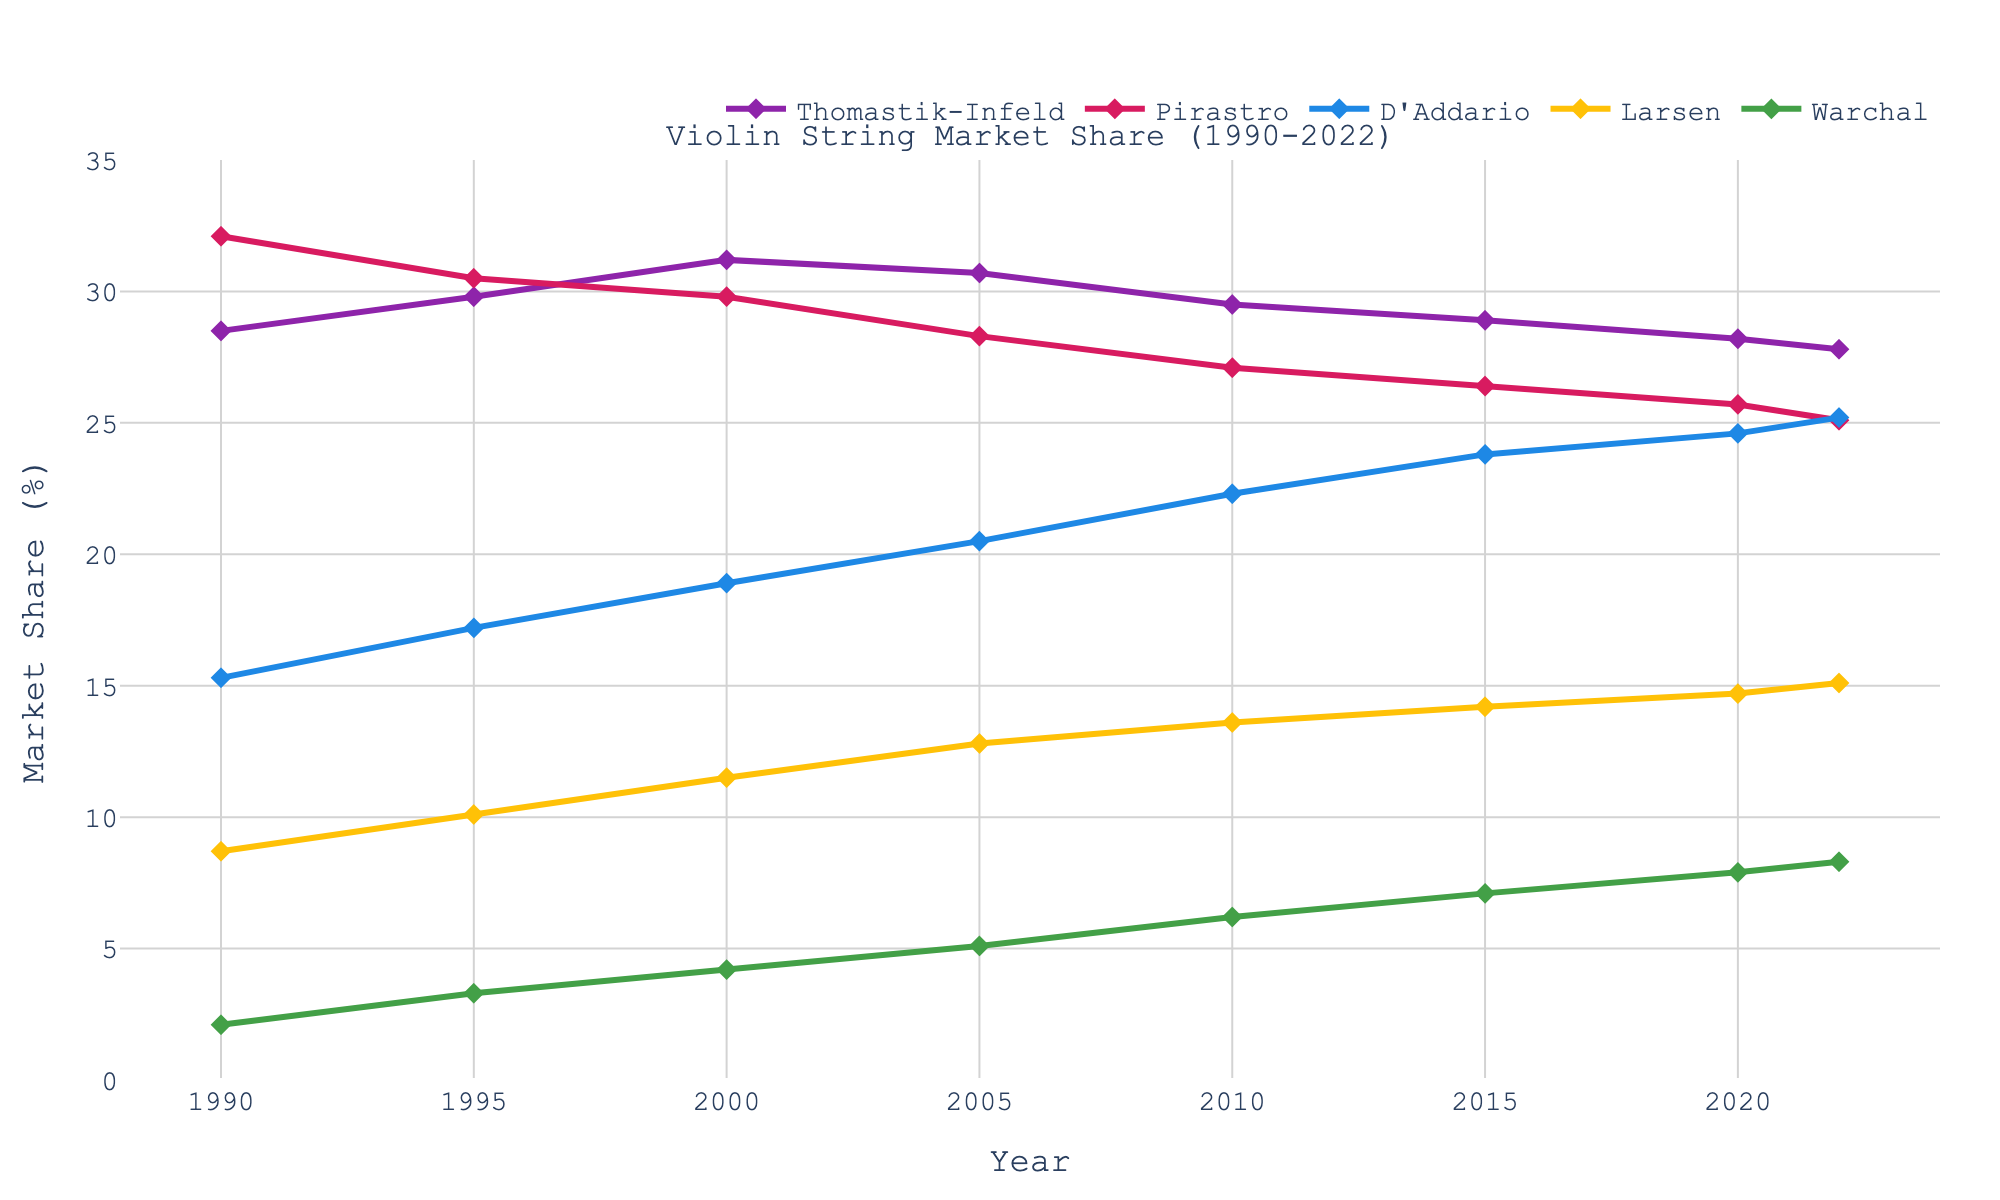Which manufacturer had the highest market share in 1990? Look at the year 1990 on the x-axis and find the highest point among the different colored lines. Thomastik-Infeld, Pirastro, D'Addario, Larsen, and Warchal are plotted. Pirastro is at the highest point with approximately 32.1%.
Answer: Pirastro What is the trend in market share for D'Addario from 1990 to 2022? Observe the D'Addario line (blue) across the years. The market share increases steadily from 15.3% in 1990 to 25.2% in 2022.
Answer: Increasing Which two manufacturers had the closest market share in 2005? Look at the year 2005 on the x-axis and compare the values for each manufacturer. Thomastik-Infeld is around 30.7%, Pirastro is around 28.3%, D'Addario is around 20.5%, Larsen is around 12.8%, and Warchal is around 5.1%. The closest values are Thomastik-Infeld and Pirastro.
Answer: Thomastik-Infeld and Pirastro What was the average market share of Larsen from 1990 to 2022? Collect the market share values for Larsen in the years given (8.7, 10.1, 11.5, 12.8, 13.6, 14.2, 14.7, 15.1). Sum them and divide by the number of values, (8.7 + 10.1 + 11.5 + 12.8 + 13.6 + 14.2 + 14.7 + 15.1)/8. This equals 12.34%.
Answer: 12.34% Which manufacturer had the smallest change in market share from 1990 to 2022? Calculate the change in market share for all manufacturers: Thomastik-Infeld (28.5 to 27.8 = -0.7), Pirastro (32.1 to 25.1 = -7.0), D'Addario (15.3 to 25.2 = +9.9), Larsen (8.7 to 15.1 = +6.4), and Warchal (2.1 to 8.3 = +6.2). The smallest change is for Thomastik-Infeld with -0.7%.
Answer: Thomastik-Infeld In 2010, which manufacturer had a market share greater than 20%? Look at the year 2010 on the x-axis and observe the values. Thomastik-Infeld is about 29.5%, Pirastro is about 27.1%, and D'Addario is about 22.3%, while Larsen is about 13.6%, and Warchal is about 6.2%. Thomastik-Infeld, Pirastro, and D'Addario all have more than 20%.
Answer: Thomastik-Infeld, Pirastro, and D'Addario Which manufacturer shows a steady increase in market share without any years of decline? Observe each line individually for consistent increase. D'Addario (blue) shows continuous increase from 1990 (15.3%) to 2022 (25.2%) without any decline in between.
Answer: D'Addario 